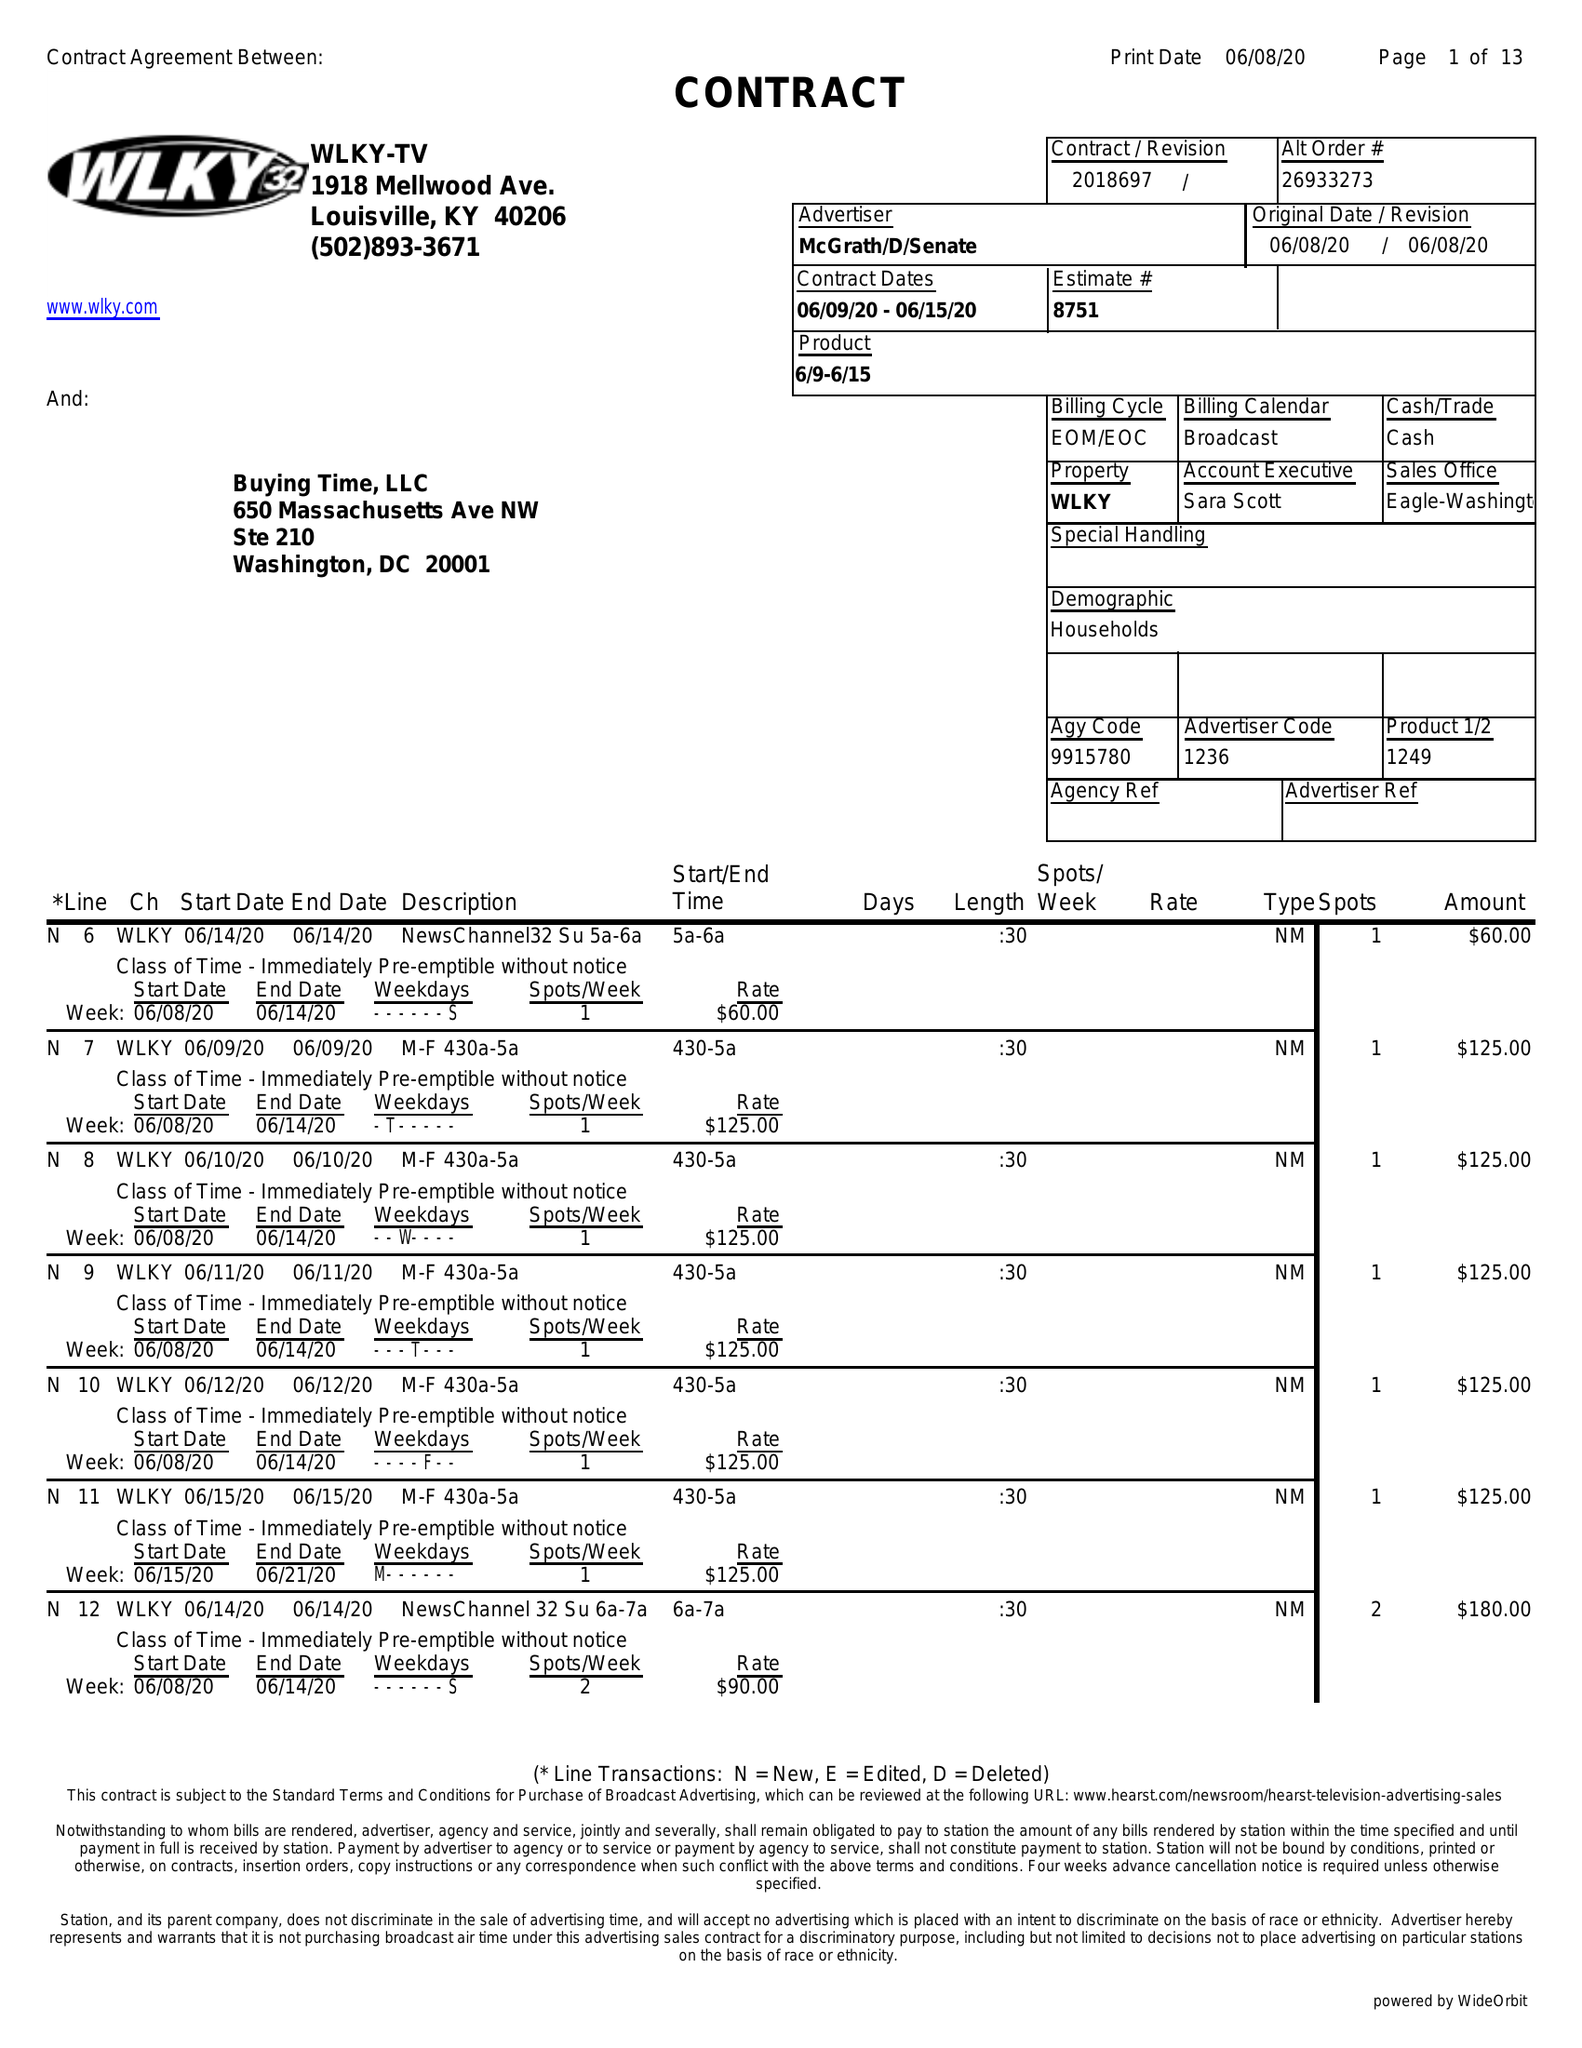What is the value for the flight_from?
Answer the question using a single word or phrase. 06/09/20 